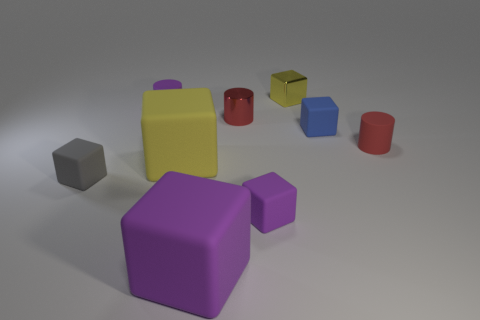Subtract all metallic blocks. How many blocks are left? 5 Subtract all blue blocks. How many blocks are left? 5 Subtract 4 blocks. How many blocks are left? 2 Add 1 small red matte blocks. How many objects exist? 10 Subtract all cyan blocks. Subtract all yellow cylinders. How many blocks are left? 6 Subtract all cylinders. How many objects are left? 6 Add 8 large yellow matte things. How many large yellow matte things are left? 9 Add 5 large gray cylinders. How many large gray cylinders exist? 5 Subtract 0 red cubes. How many objects are left? 9 Subtract all tiny purple rubber cylinders. Subtract all tiny purple cylinders. How many objects are left? 7 